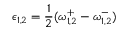<formula> <loc_0><loc_0><loc_500><loc_500>\epsilon _ { 1 , 2 } = \frac { 1 } { 2 } ( \omega _ { 1 , 2 } ^ { + } - \omega _ { 1 , 2 } ^ { - } )</formula> 